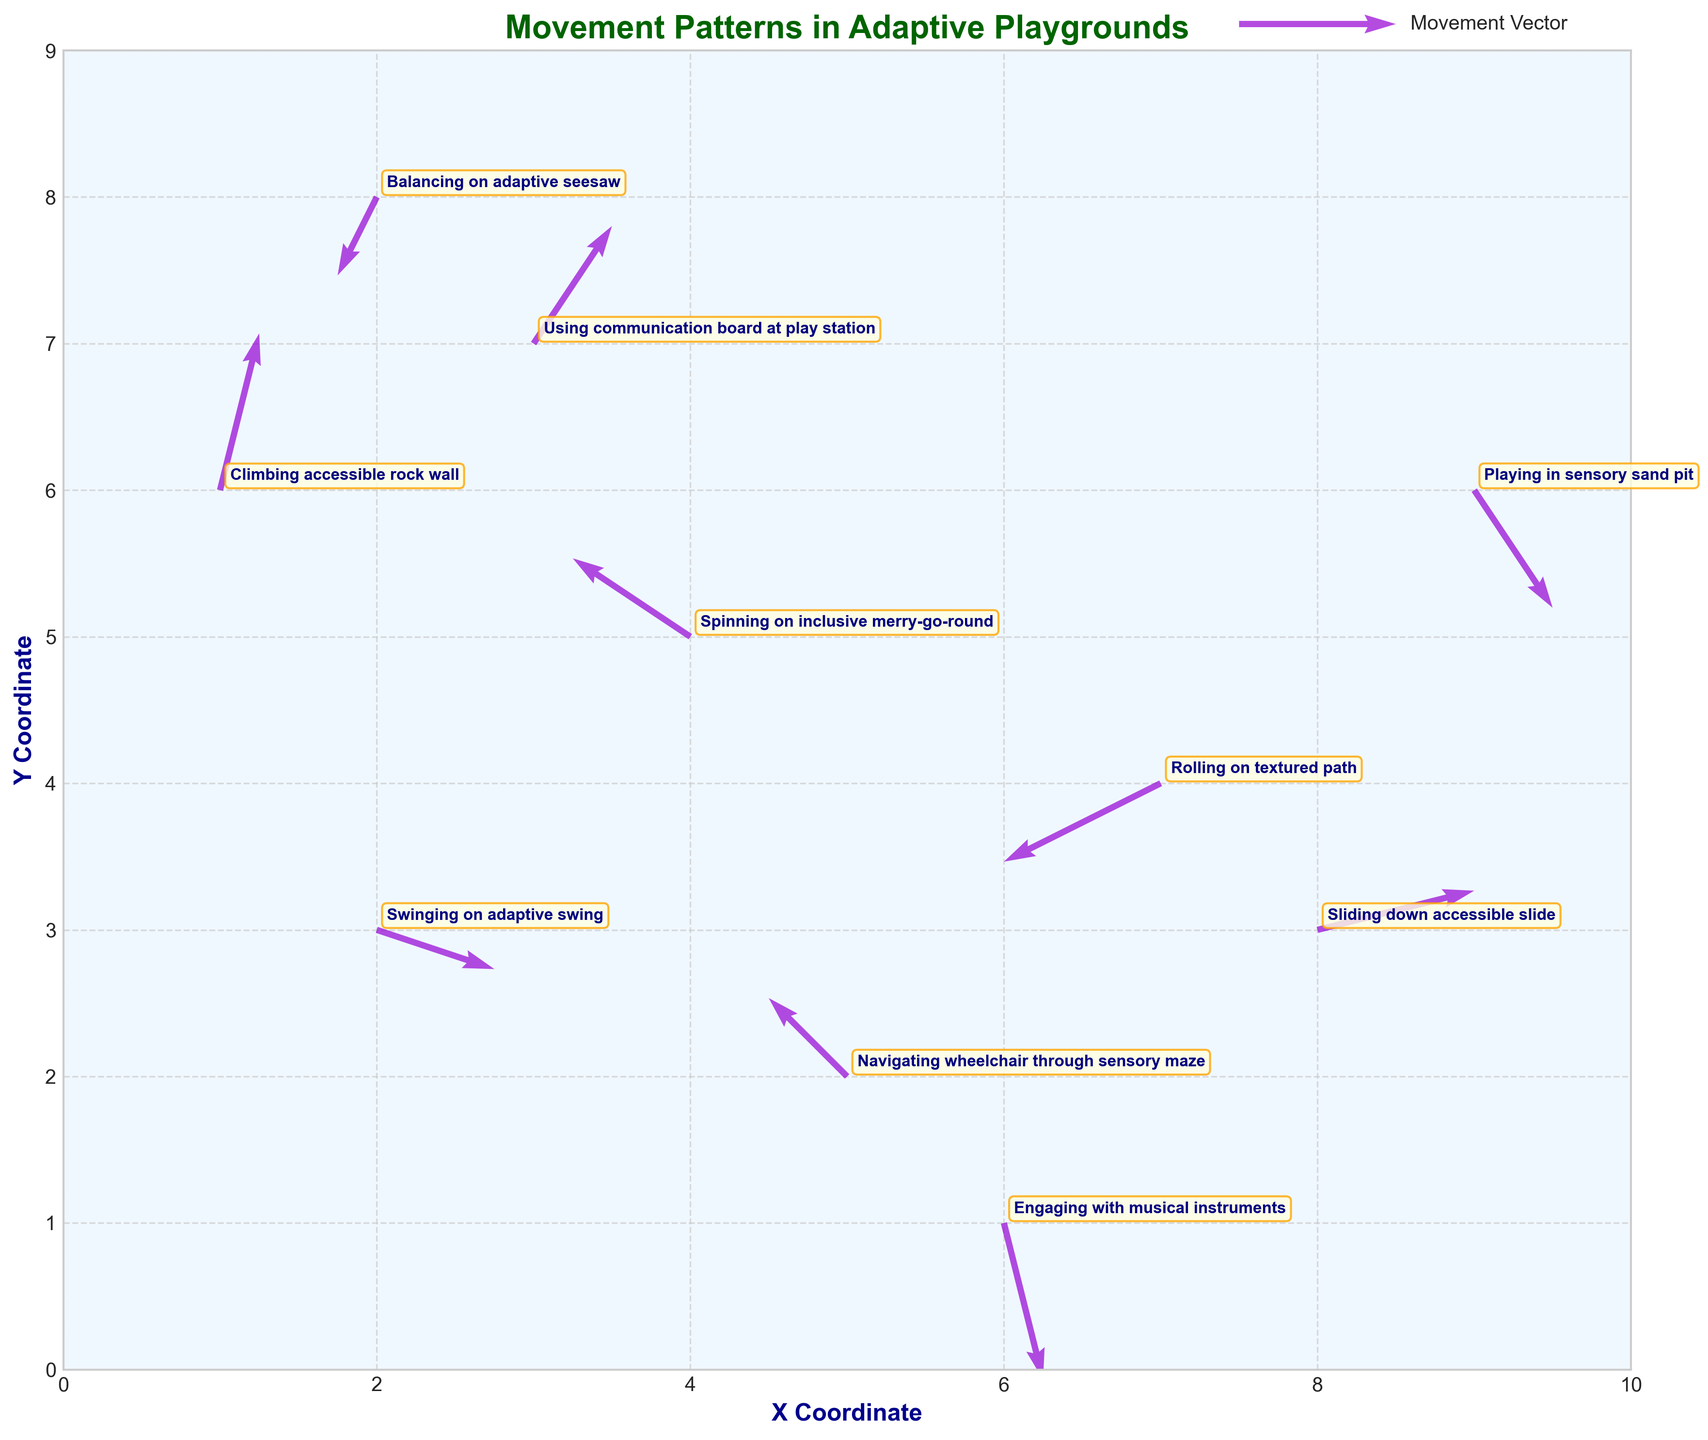What's the title of the plot? The plot's title is written at the top center of the plot, in bold and dark green. It reads "Movement Patterns in Adaptive Playgrounds".
Answer: Movement Patterns in Adaptive Playgrounds What are the labels for the X and Y axes? The labels for the X and Y axes are found just below the respective axes in bold, dark blue font. The X-axis is labeled "X Coordinate" and the Y-axis is labeled "Y Coordinate".
Answer: X Coordinate and Y Coordinate How many movement vectors are depicted in the plot? To determine the number of movement vectors, count the number of arrows shown on the plot. Each arrow represents a data point. By counting, there are a total of 10 arrows.
Answer: 10 Which activity shows movement with a vector going upwards and to the right? Examine the direction of the arrows and look for the corresponding annotation. The vector at (1,6) has its arrow pointing up and to the right and is labeled "Climbing accessible rock wall".
Answer: Climbing accessible rock wall Which activity has the largest upward movement component? To identify the largest upward movement, compare the vertical components (v-values) of all vectors. The (1,6) vector with v = 2 has the largest vertical component and corresponds to "Climbing accessible rock wall".
Answer: Climbing accessible rock wall What is the difference in vertical movement component between the activities at (2,3) and (9,6)? The vertical movement component for (2,3) is -0.5 (Swinging on adaptive swing), and for (9,6) it is -1.5 (Playing in sensory sand pit). The difference is calculated as: -0.5 - (-1.5) = 1.
Answer: 1 Which two activities have vectors moving in opposite directions in terms of the horizontal component? Compare the horizontal components (u-values) of vectors. The vector at (7,4) has u=-2 (Rolling on textured path), and the vector at (8,3) has u=2 (Sliding down accessible slide), which move in opposite horizontal directions.
Answer: Rolling on textured path and Sliding down accessible slide Between the activities at coordinates (4,5) and (5,2), which has the higher overall vector magnitude? Calculate the vector magnitude using the formula √(u² + v²). For (4,5): √((-1.5)² + 1²) ≈ 1.8, and for (5,2): √((-1)² + 1²) ≈ 1.4. The vector at (4,5) has a higher magnitude.
Answer: Spinning on inclusive merry-go-round Which activity has the vector with both horizontal and vertical components being negative? Look for vectors where both u and v components are negative. The vector at (7,4) with u=-2 and v=-1 (Rolling on textured path) fits this criteria.
Answer: Rolling on textured path 